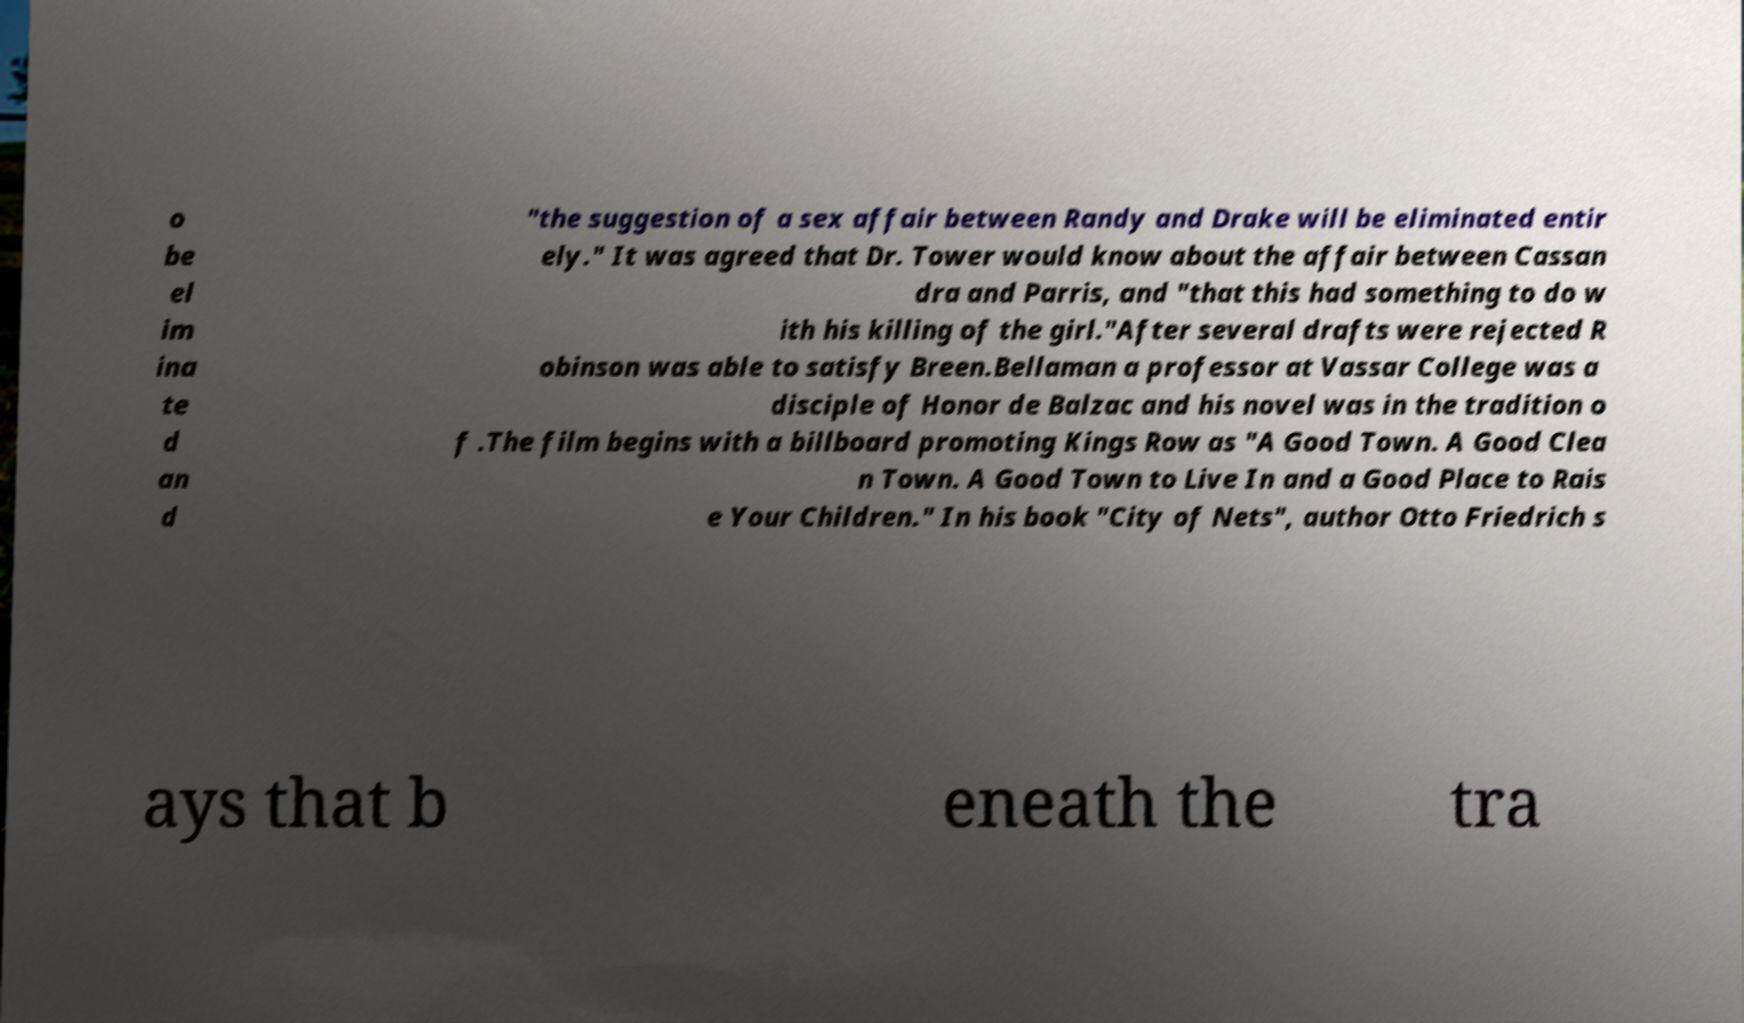Can you accurately transcribe the text from the provided image for me? o be el im ina te d an d "the suggestion of a sex affair between Randy and Drake will be eliminated entir ely." It was agreed that Dr. Tower would know about the affair between Cassan dra and Parris, and "that this had something to do w ith his killing of the girl."After several drafts were rejected R obinson was able to satisfy Breen.Bellaman a professor at Vassar College was a disciple of Honor de Balzac and his novel was in the tradition o f .The film begins with a billboard promoting Kings Row as "A Good Town. A Good Clea n Town. A Good Town to Live In and a Good Place to Rais e Your Children." In his book "City of Nets", author Otto Friedrich s ays that b eneath the tra 